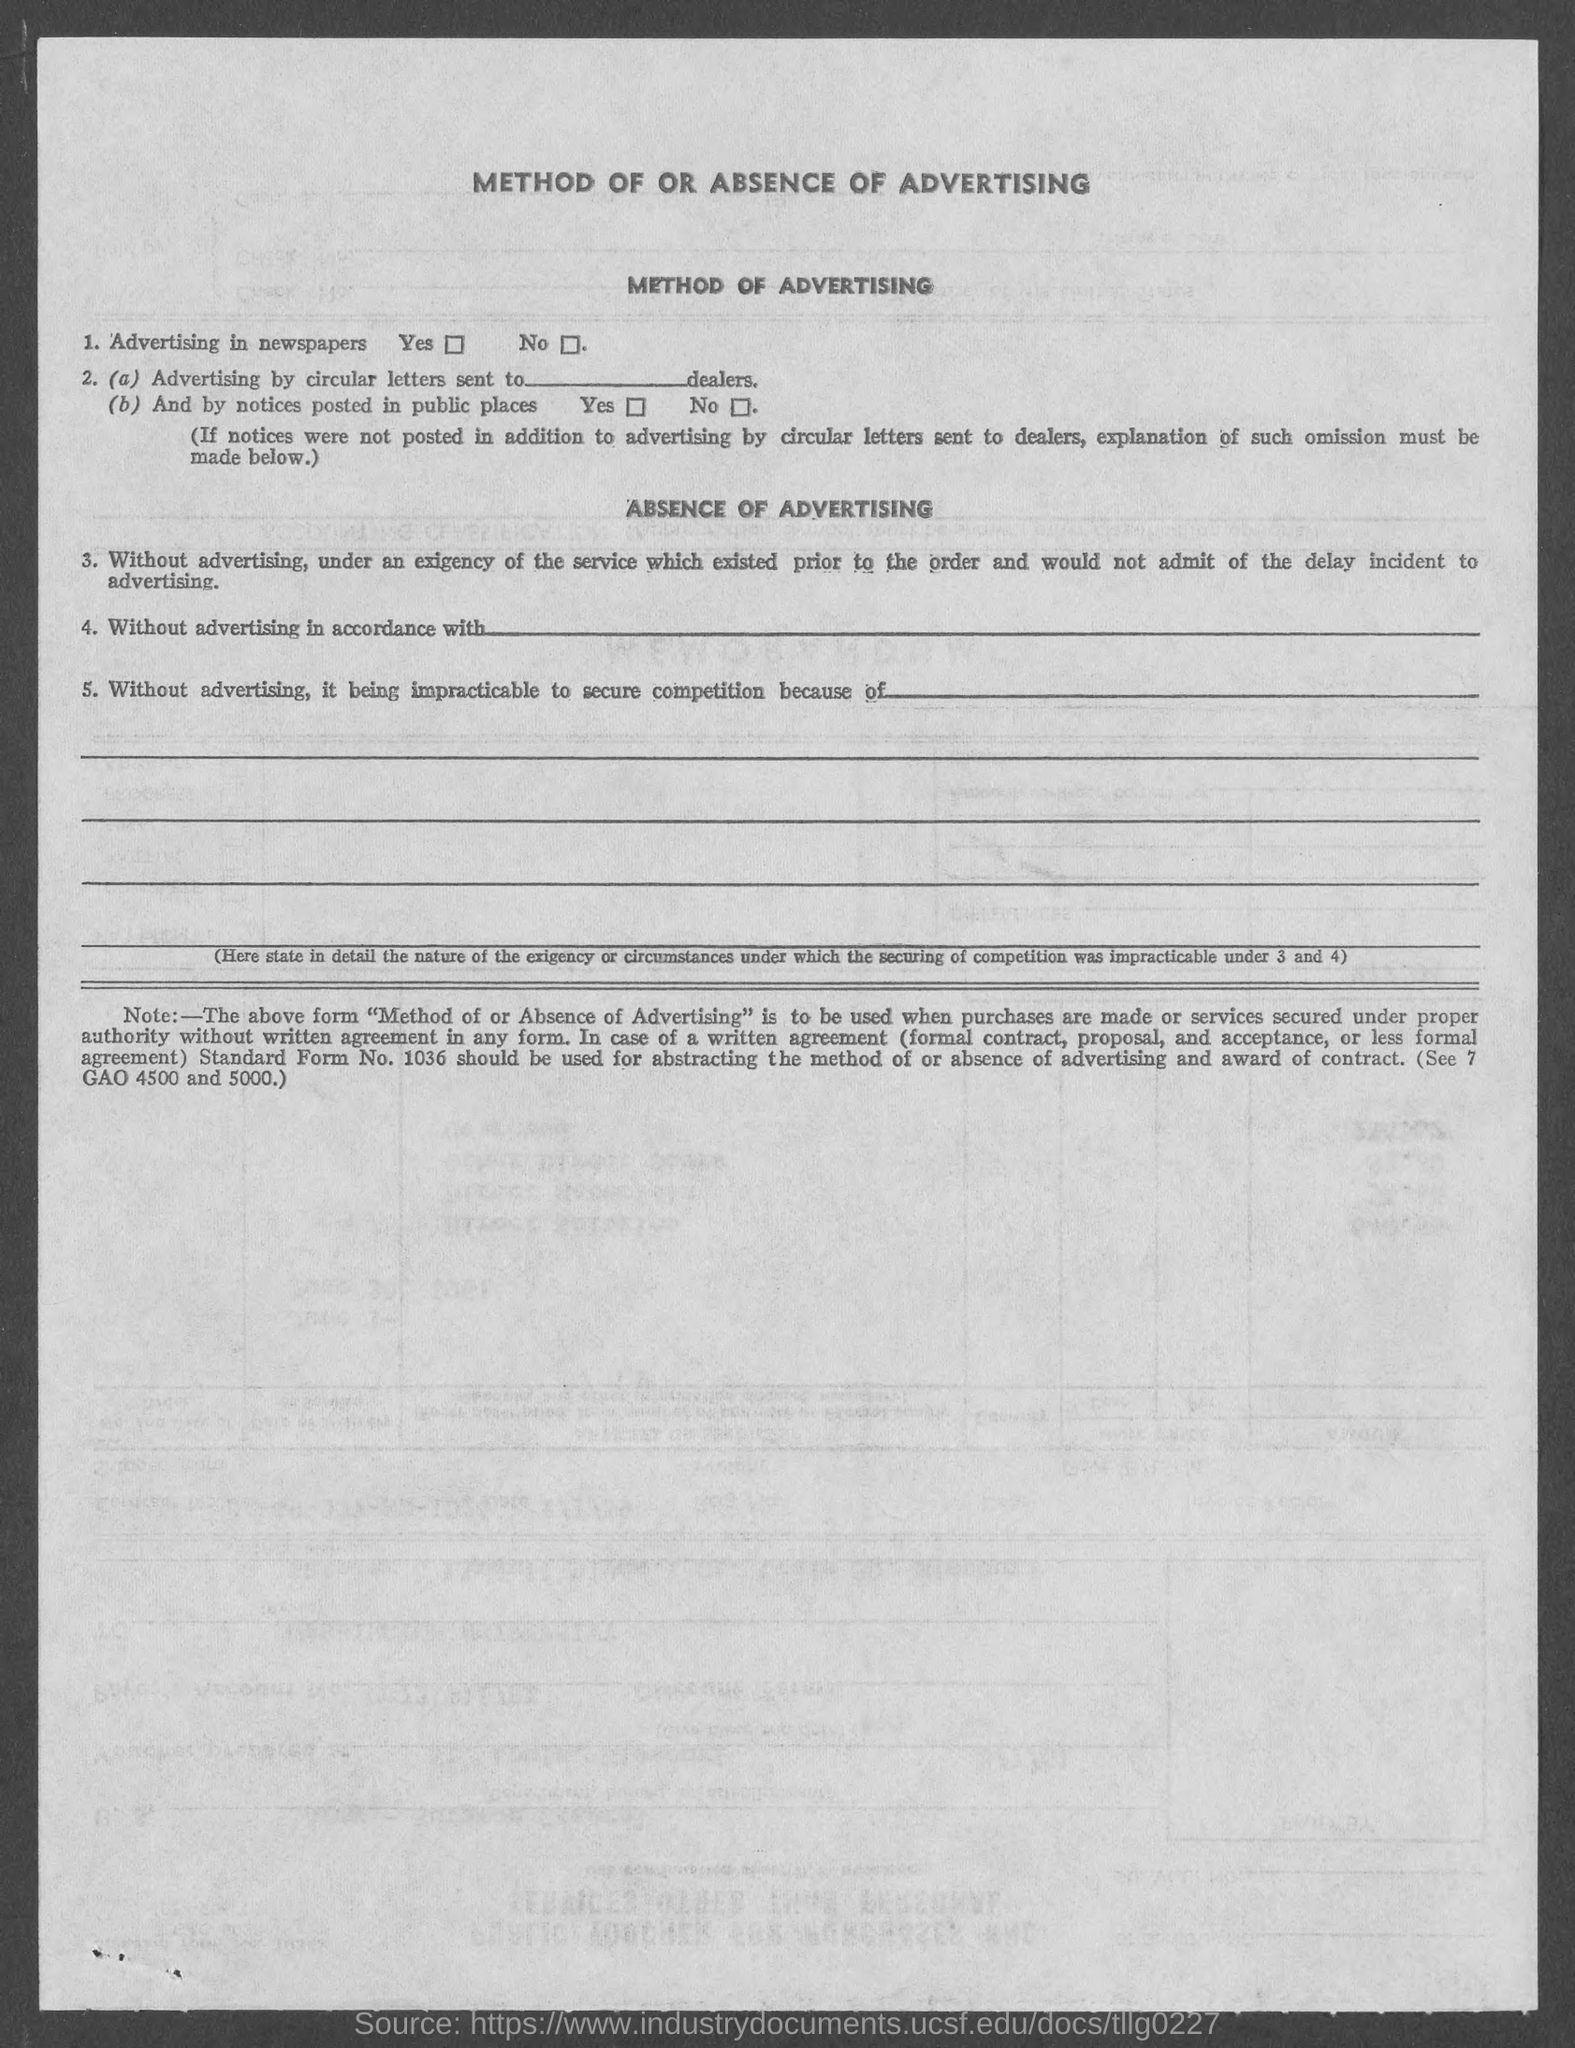What is the heading at top of the page ?
Keep it short and to the point. Method of or absence of advertising. 